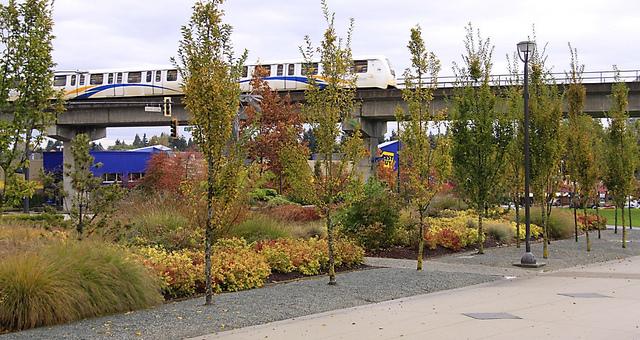Is the train on a bridge?
Write a very short answer. Yes. Is the street light on?
Concise answer only. No. Is the train on the ground?
Keep it brief. No. Are the flowers beautiful?
Answer briefly. No. 